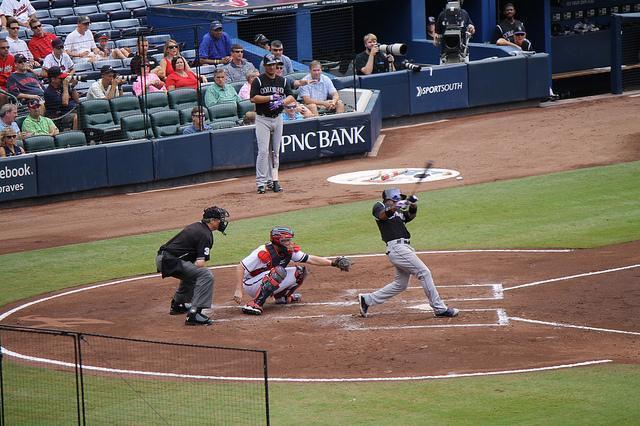Who is an all-time legend for one of these teams?
Indicate the correct response by choosing from the four available options to answer the question.
Options: Michael jordan, leroy garrett, todd helton, tom brady. Todd helton. 